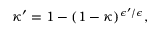Convert formula to latex. <formula><loc_0><loc_0><loc_500><loc_500>\kappa ^ { \prime } = 1 - ( 1 - \kappa ) ^ { \epsilon ^ { \prime } / \epsilon } ,</formula> 